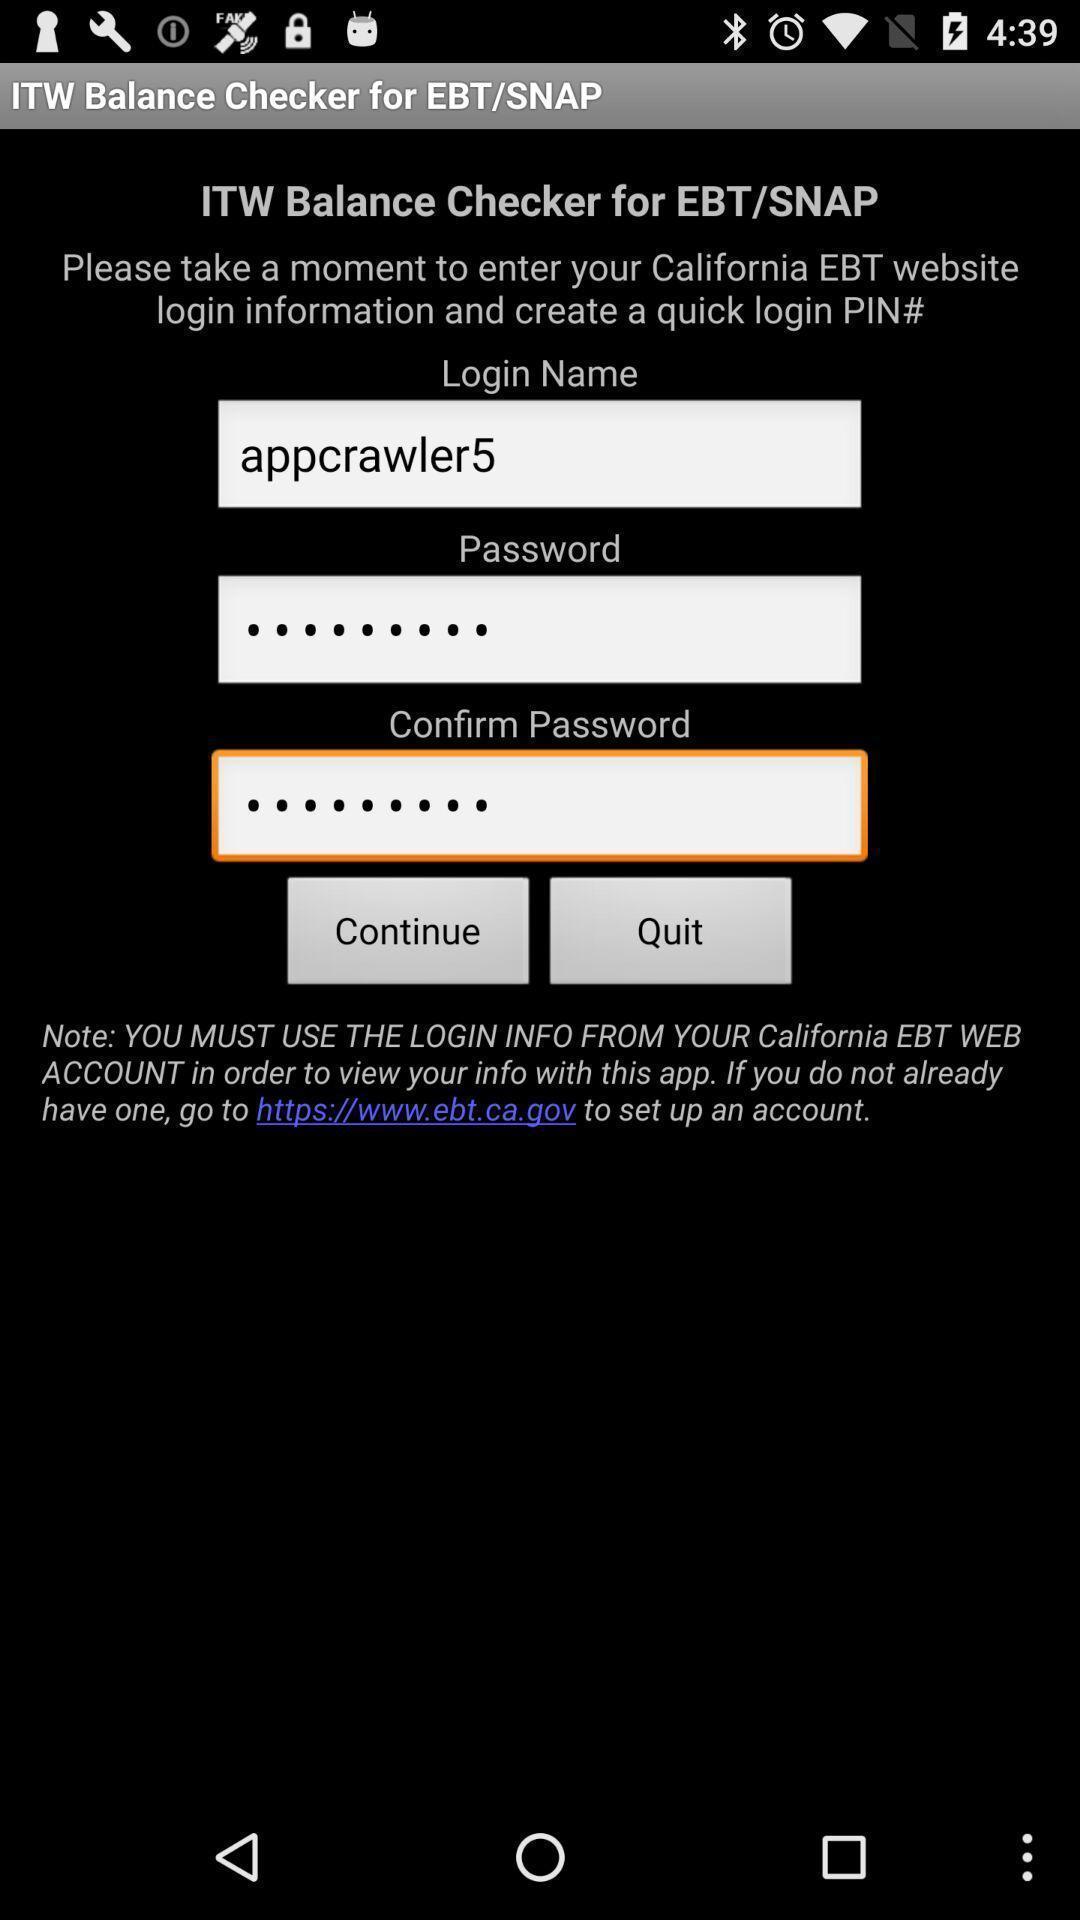Tell me about the visual elements in this screen capture. Screen displaying user information in login page. 